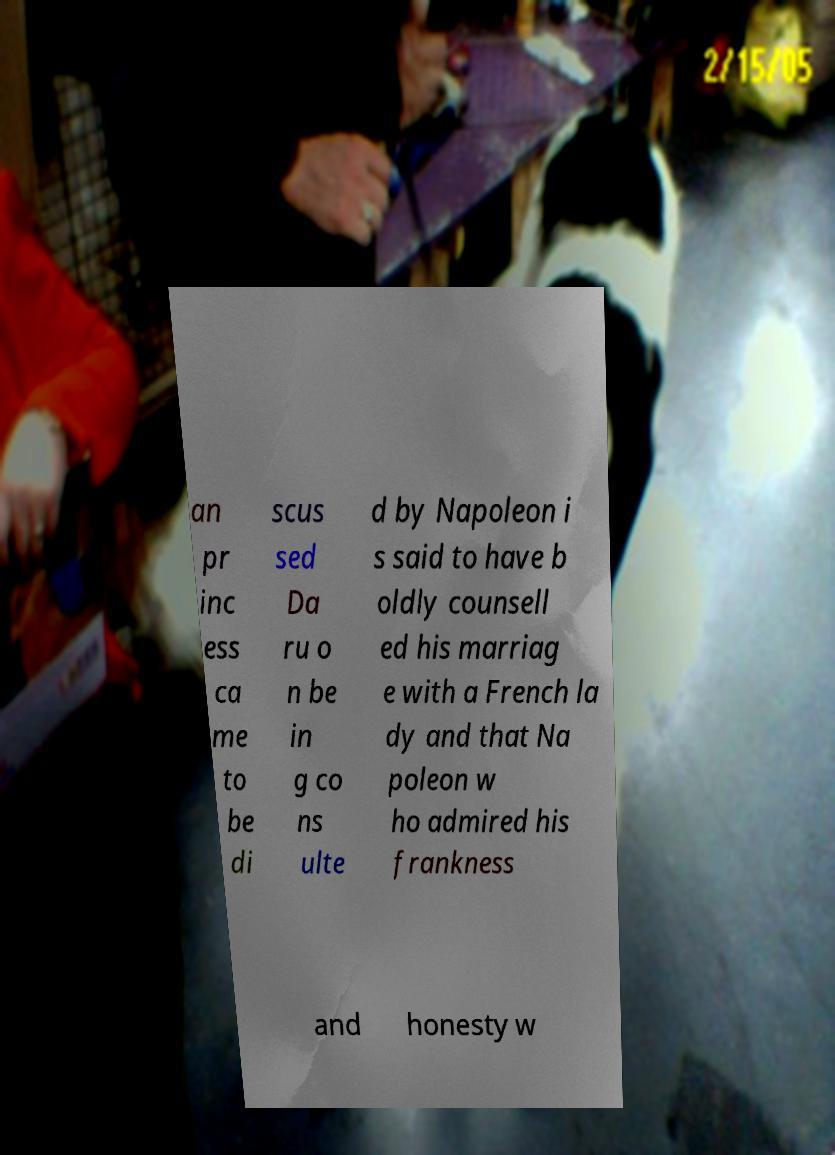Can you accurately transcribe the text from the provided image for me? an pr inc ess ca me to be di scus sed Da ru o n be in g co ns ulte d by Napoleon i s said to have b oldly counsell ed his marriag e with a French la dy and that Na poleon w ho admired his frankness and honesty w 